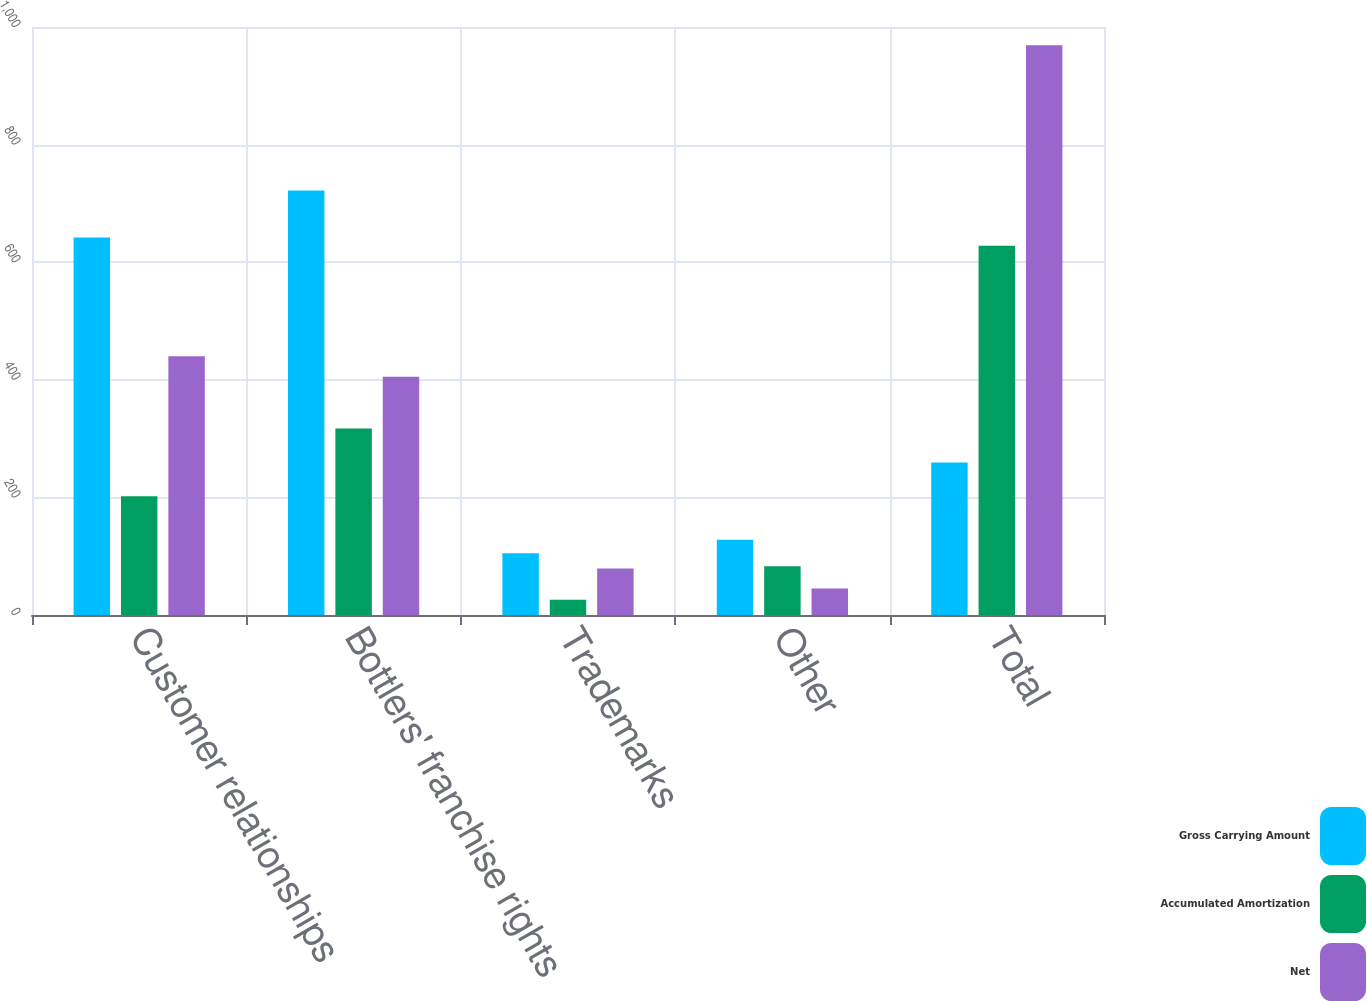<chart> <loc_0><loc_0><loc_500><loc_500><stacked_bar_chart><ecel><fcel>Customer relationships<fcel>Bottlers' franchise rights<fcel>Trademarks<fcel>Other<fcel>Total<nl><fcel>Gross Carrying Amount<fcel>642<fcel>722<fcel>105<fcel>128<fcel>259.5<nl><fcel>Accumulated Amortization<fcel>202<fcel>317<fcel>26<fcel>83<fcel>628<nl><fcel>Net<fcel>440<fcel>405<fcel>79<fcel>45<fcel>969<nl></chart> 